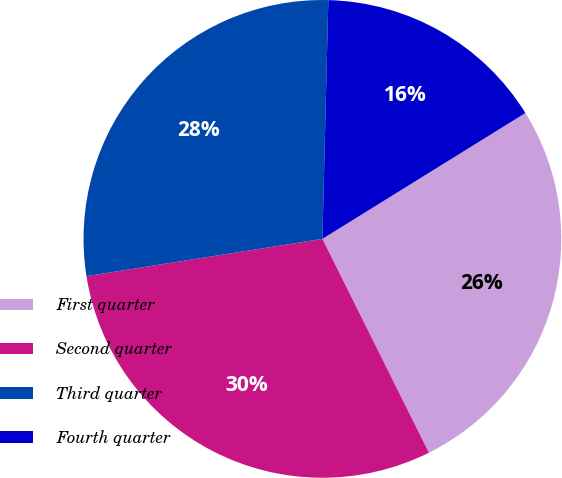<chart> <loc_0><loc_0><loc_500><loc_500><pie_chart><fcel>First quarter<fcel>Second quarter<fcel>Third quarter<fcel>Fourth quarter<nl><fcel>26.48%<fcel>29.86%<fcel>27.89%<fcel>15.77%<nl></chart> 